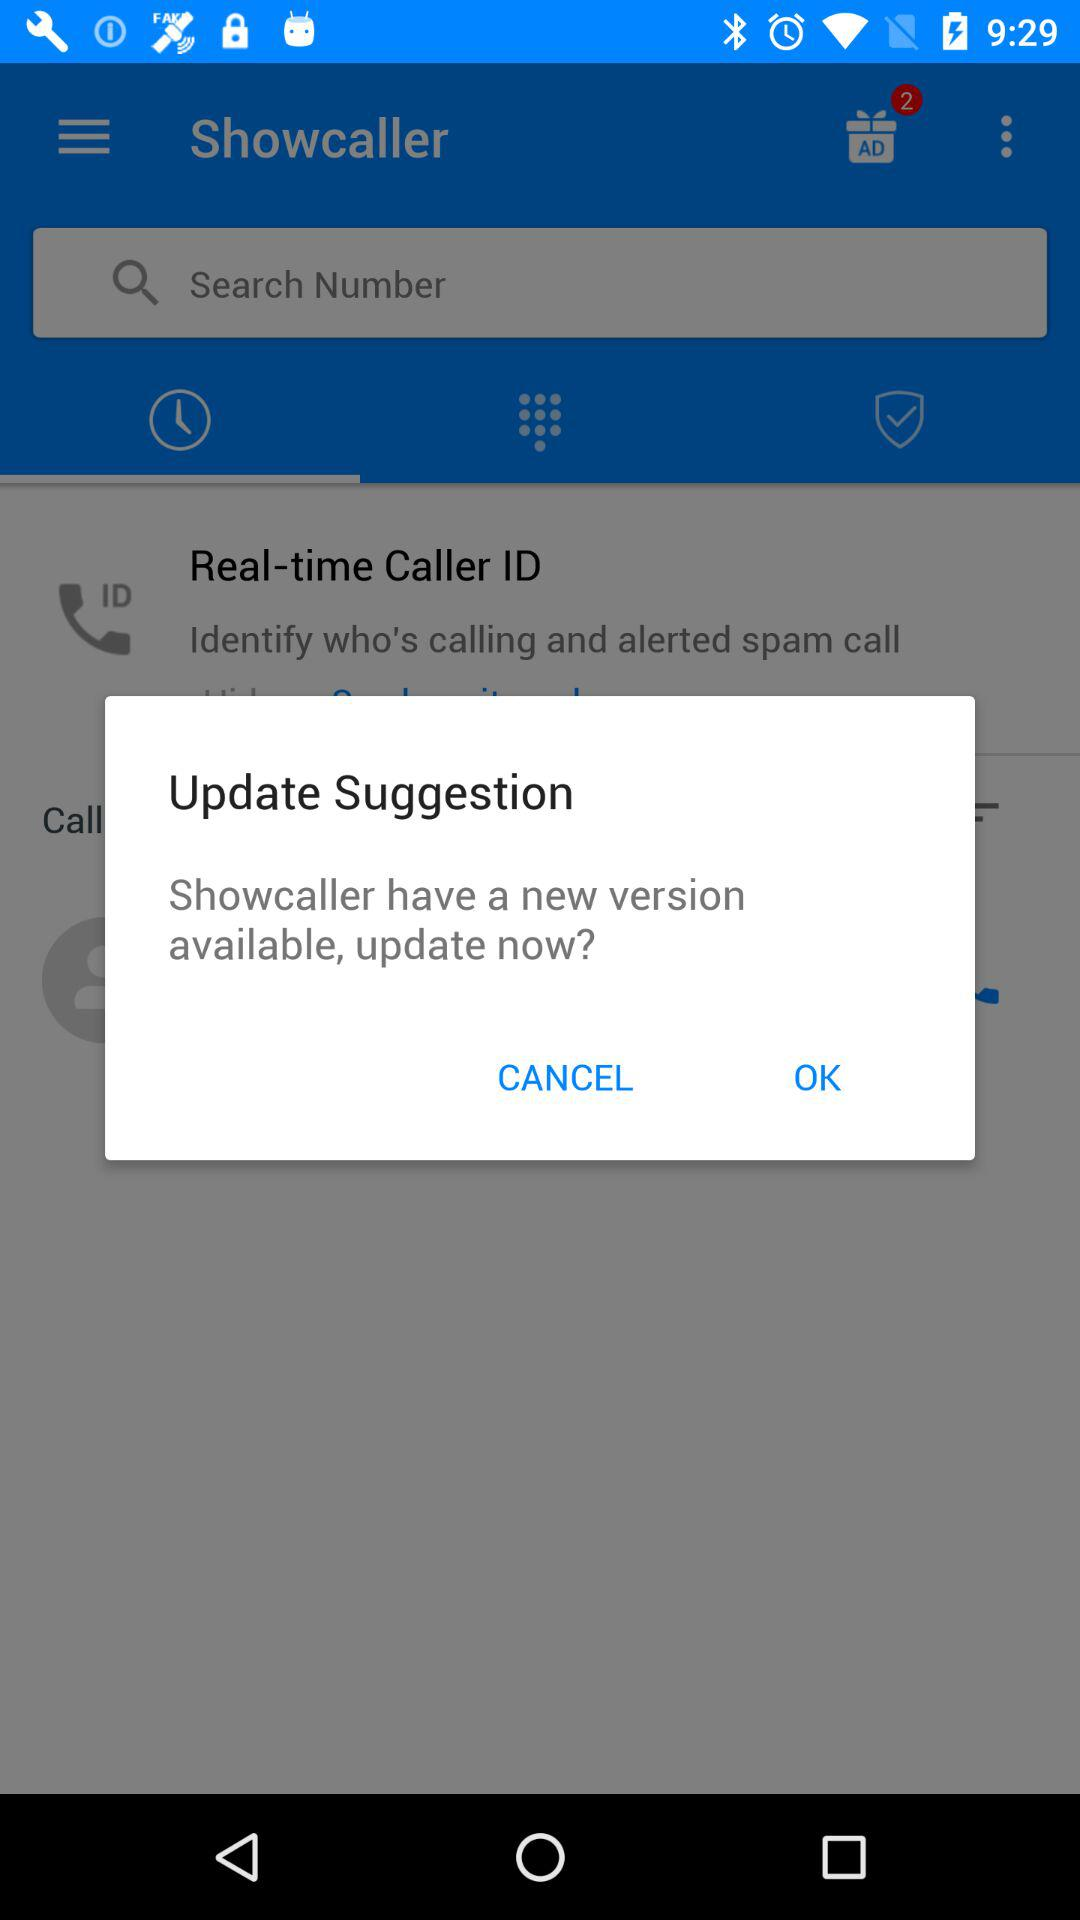What is the name of the application? The name of the application is "Showcaller". 